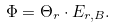<formula> <loc_0><loc_0><loc_500><loc_500>\Phi = \Theta _ { r } \cdot E _ { r , B } .</formula> 